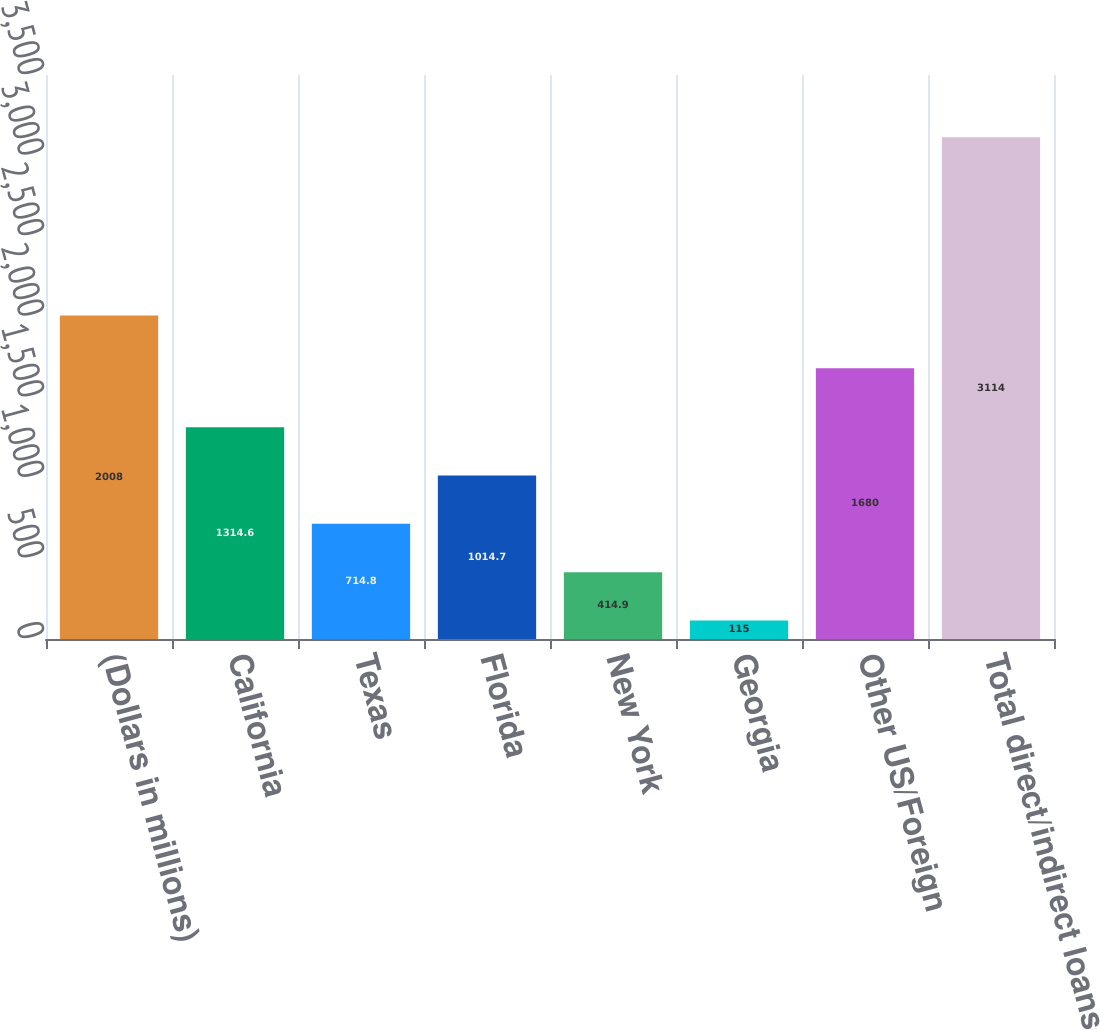<chart> <loc_0><loc_0><loc_500><loc_500><bar_chart><fcel>(Dollars in millions)<fcel>California<fcel>Texas<fcel>Florida<fcel>New York<fcel>Georgia<fcel>Other US/Foreign<fcel>Total direct/indirect loans<nl><fcel>2008<fcel>1314.6<fcel>714.8<fcel>1014.7<fcel>414.9<fcel>115<fcel>1680<fcel>3114<nl></chart> 